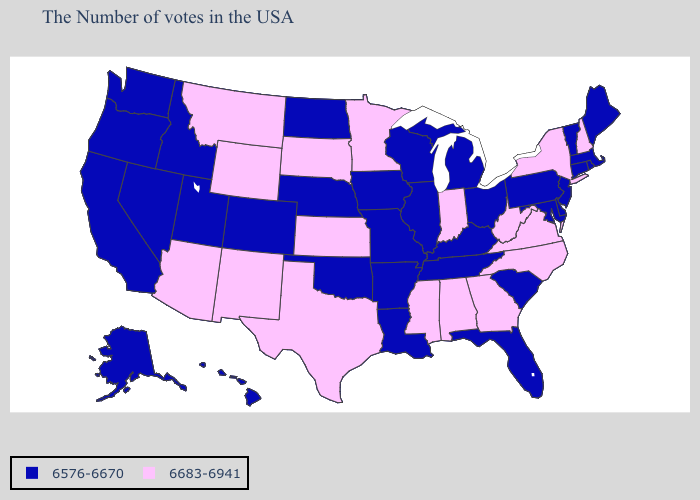Among the states that border Pennsylvania , does Delaware have the highest value?
Concise answer only. No. Name the states that have a value in the range 6683-6941?
Write a very short answer. New Hampshire, New York, Virginia, North Carolina, West Virginia, Georgia, Indiana, Alabama, Mississippi, Minnesota, Kansas, Texas, South Dakota, Wyoming, New Mexico, Montana, Arizona. What is the value of Maryland?
Short answer required. 6576-6670. Does Hawaii have the highest value in the USA?
Give a very brief answer. No. What is the value of South Dakota?
Give a very brief answer. 6683-6941. Among the states that border New Mexico , which have the lowest value?
Keep it brief. Oklahoma, Colorado, Utah. Among the states that border New York , which have the highest value?
Give a very brief answer. Massachusetts, Vermont, Connecticut, New Jersey, Pennsylvania. Does Wyoming have a higher value than Utah?
Write a very short answer. Yes. What is the lowest value in states that border Kentucky?
Short answer required. 6576-6670. What is the highest value in the West ?
Keep it brief. 6683-6941. What is the value of Nebraska?
Answer briefly. 6576-6670. What is the value of Utah?
Write a very short answer. 6576-6670. Which states have the lowest value in the West?
Be succinct. Colorado, Utah, Idaho, Nevada, California, Washington, Oregon, Alaska, Hawaii. Name the states that have a value in the range 6683-6941?
Be succinct. New Hampshire, New York, Virginia, North Carolina, West Virginia, Georgia, Indiana, Alabama, Mississippi, Minnesota, Kansas, Texas, South Dakota, Wyoming, New Mexico, Montana, Arizona. What is the lowest value in the South?
Keep it brief. 6576-6670. 